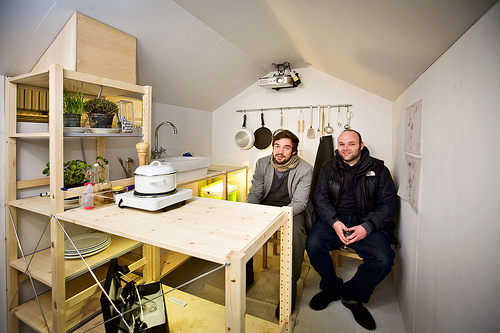<image>
Can you confirm if the pot is behind the man? Yes. From this viewpoint, the pot is positioned behind the man, with the man partially or fully occluding the pot. Is the table on the man? No. The table is not positioned on the man. They may be near each other, but the table is not supported by or resting on top of the man. 